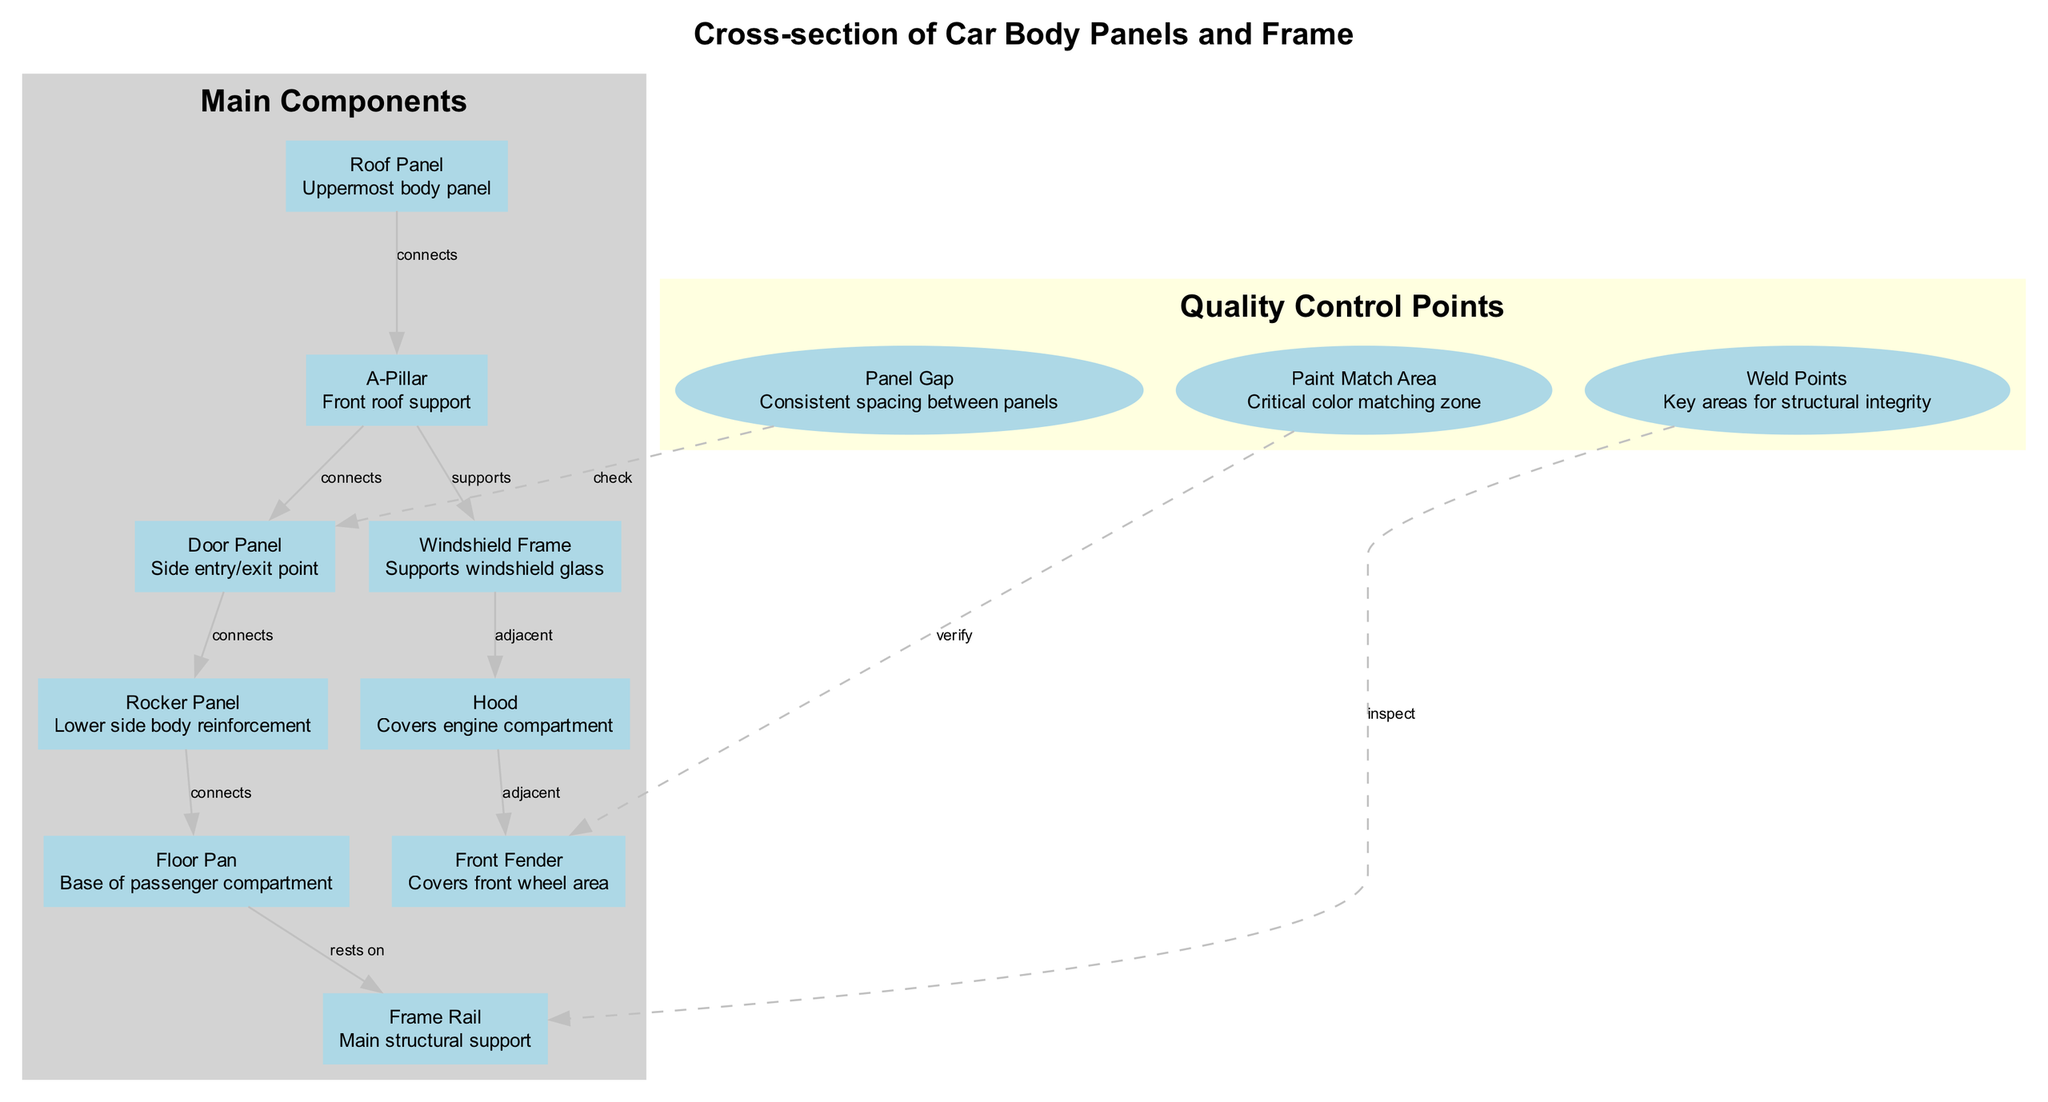What is the uppermost body panel? The diagram labels the "Roof Panel" as the uppermost body panel. This can be identified as it is positioned at the top of the diagram within the main components section.
Answer: Roof Panel Which component supports the windshield glass? According to the diagram, the "Windshield Frame" is described specifically as supporting the windshield glass. This direct connection can be seen in the labeled node.
Answer: Windshield Frame How many main components are there? Upon reviewing the diagram, there are 8 distinct nodes labeled under "Main Components." Each component can be counted individually to arrive at the total.
Answer: 8 Which quality control point is connected to the Door Panel? The diagram shows a dashed edge labeled "check" that connects "Panel Gap" to "Door Panel." This indicates a quality control point relevant to the Door Panel specifically.
Answer: Panel Gap What is the critical color matching zone? The diagram explicitly labels "Paint Match Area" as the critical zone for color matching. This can be seen in the quality control points section of the diagram.
Answer: Paint Match Area How does the Rocker Panel connect to the Floor Pan? The diagram indicates a direct connection from the "Rocker Panel" to the "Floor Pan," stating that the Rocker Panel "connects" to it, showing the structural relationship between these components.
Answer: Connects Which main component rests on the Frame Rail? From the diagram, it shows that the "Floor Pan" rests on the "Frame Rail," indicating a supportive structural relationship between these two components.
Answer: Floor Pan What is the key area for structural integrity? Within the quality control points, "Weld Points" is identified as key areas for structural integrity. This is explicitly labeled in the quality control section of the diagram.
Answer: Weld Points How many edges connect the Roof Panel to other components? The diagram indicates two edges originating from the "Roof Panel"—one connecting to the "A-Pillar" and the other to the "Windshield Frame." By tracing the edges, we find both connections.
Answer: 2 